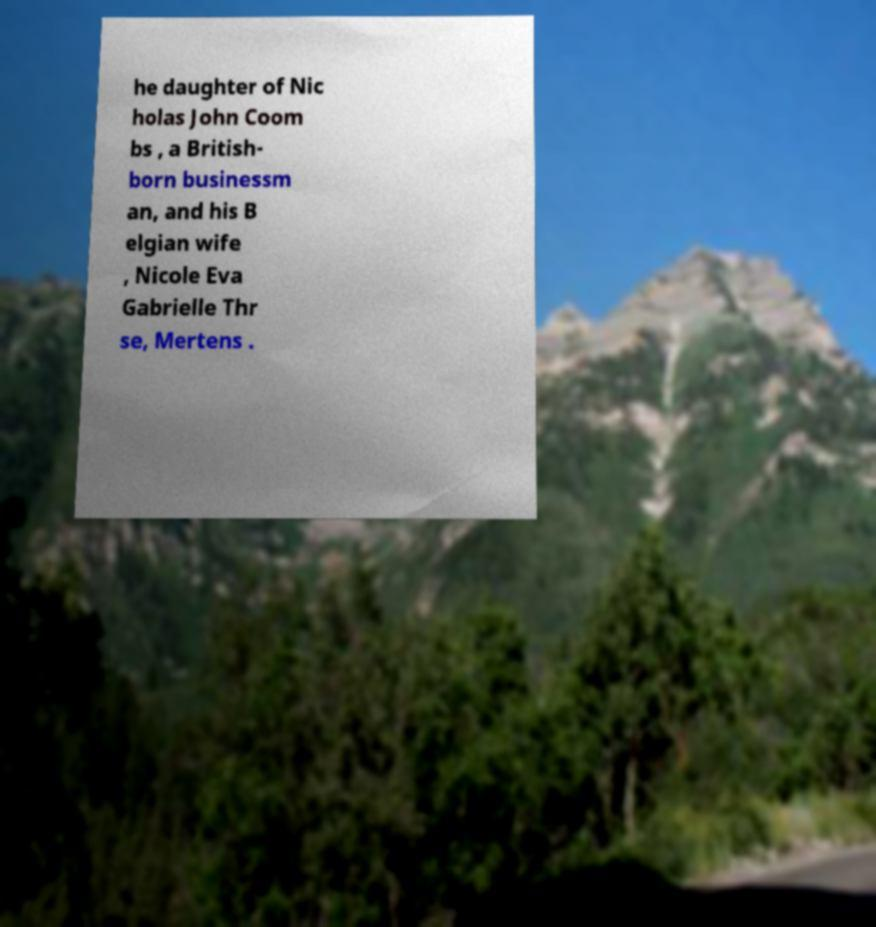Could you assist in decoding the text presented in this image and type it out clearly? he daughter of Nic holas John Coom bs , a British- born businessm an, and his B elgian wife , Nicole Eva Gabrielle Thr se, Mertens . 